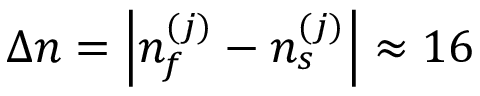<formula> <loc_0><loc_0><loc_500><loc_500>\Delta n = \left | { n _ { f } ^ { ( j ) } - n _ { s } ^ { ( j ) } } \right | \approx 1 6</formula> 